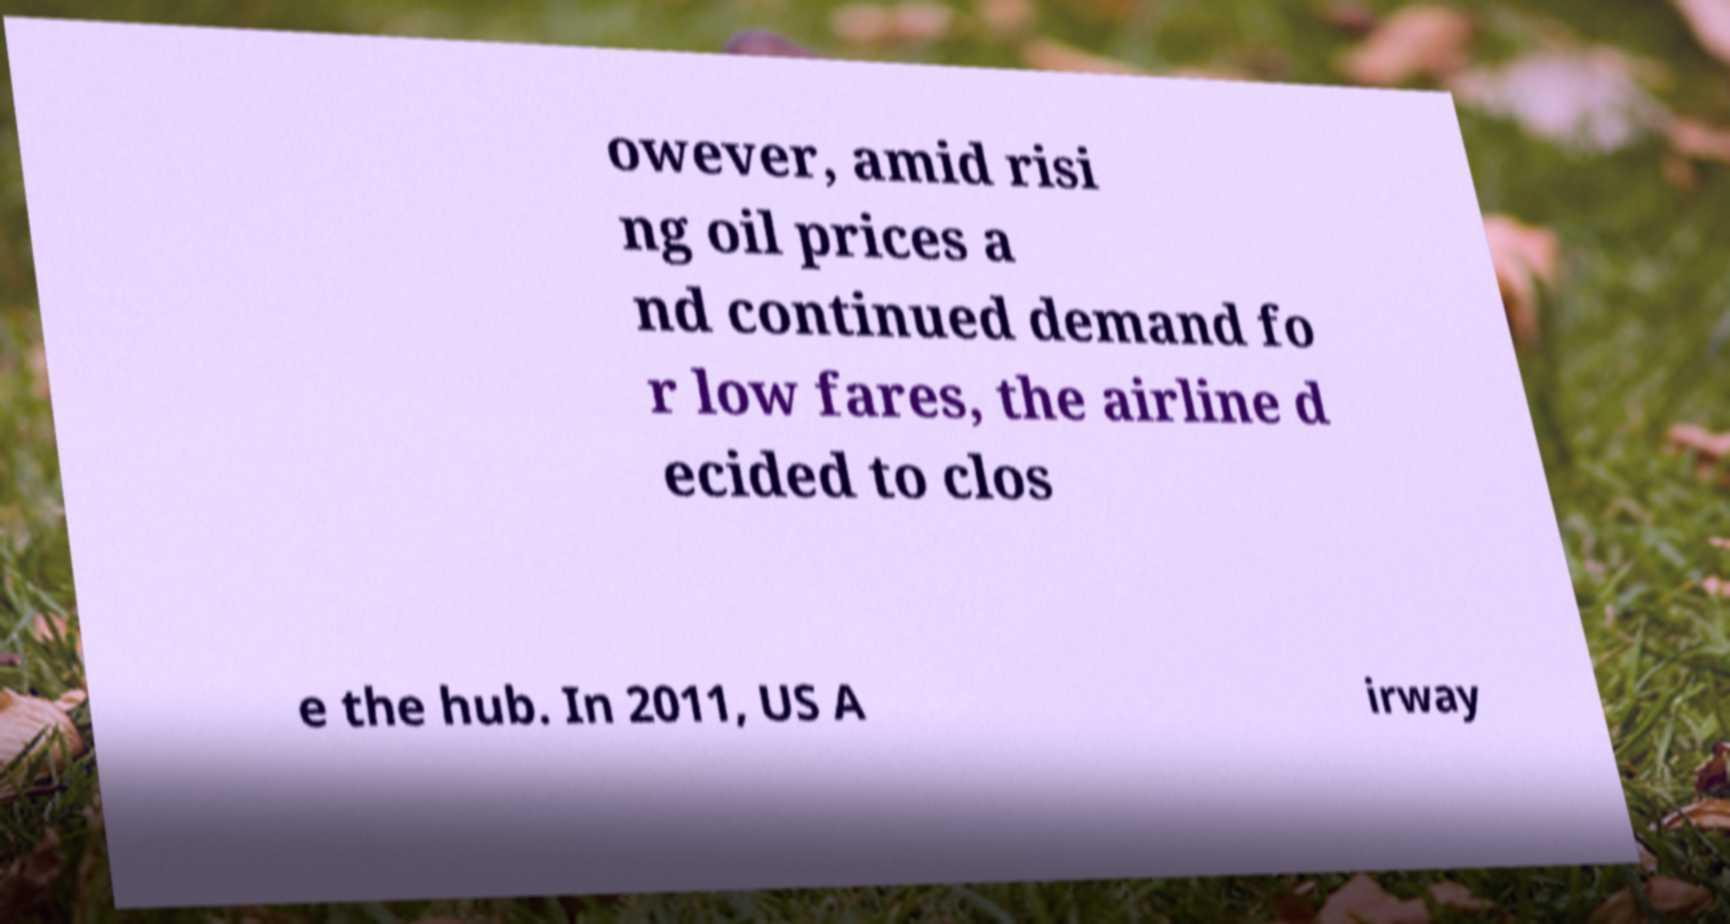For documentation purposes, I need the text within this image transcribed. Could you provide that? owever, amid risi ng oil prices a nd continued demand fo r low fares, the airline d ecided to clos e the hub. In 2011, US A irway 